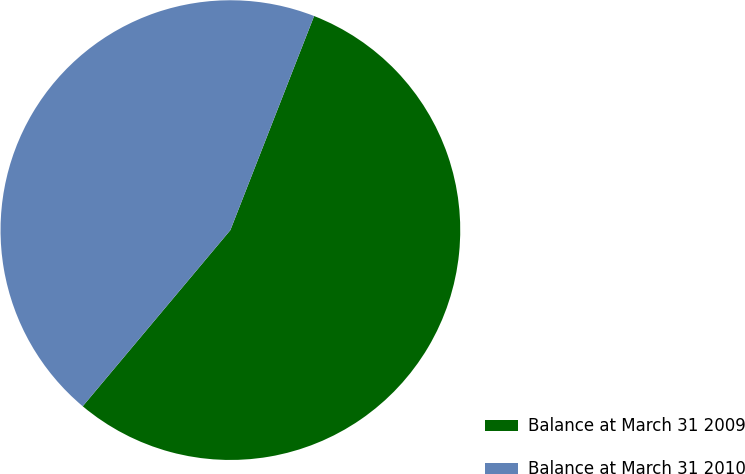Convert chart to OTSL. <chart><loc_0><loc_0><loc_500><loc_500><pie_chart><fcel>Balance at March 31 2009<fcel>Balance at March 31 2010<nl><fcel>55.17%<fcel>44.83%<nl></chart> 